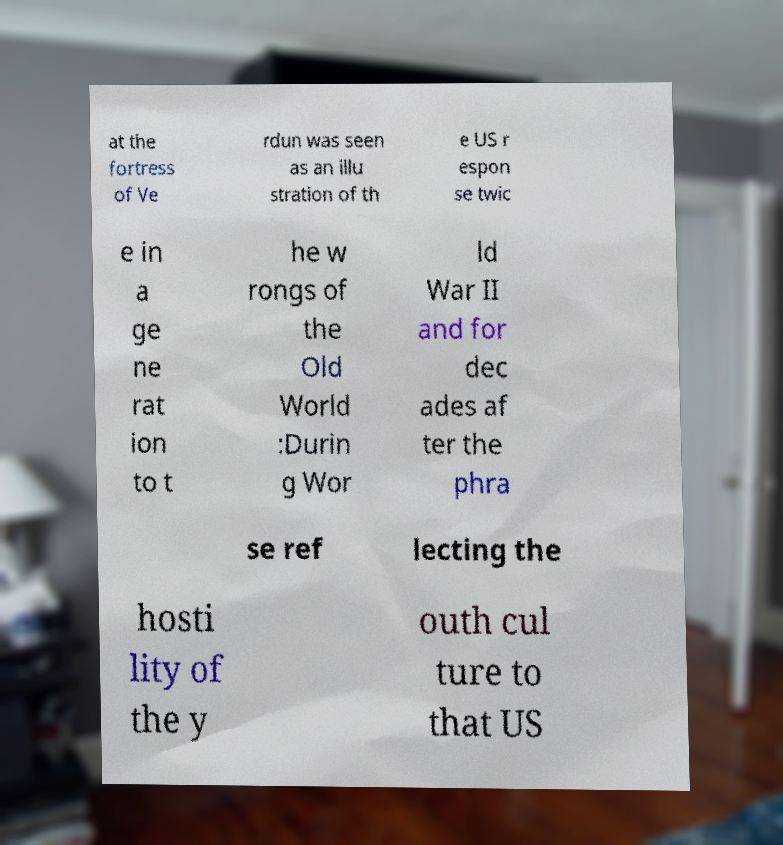For documentation purposes, I need the text within this image transcribed. Could you provide that? at the fortress of Ve rdun was seen as an illu stration of th e US r espon se twic e in a ge ne rat ion to t he w rongs of the Old World :Durin g Wor ld War II and for dec ades af ter the phra se ref lecting the hosti lity of the y outh cul ture to that US 